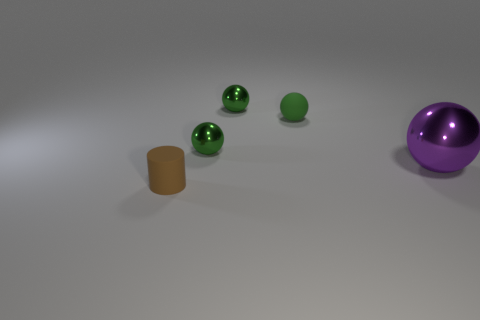Do the small thing that is in front of the large purple metallic object and the tiny sphere that is behind the matte sphere have the same material?
Your answer should be compact. No. There is a tiny green object that is on the right side of the tiny green object behind the rubber ball on the left side of the purple ball; what is its material?
Keep it short and to the point. Rubber. There is a big purple sphere; are there any tiny cylinders in front of it?
Provide a short and direct response. Yes. What is the shape of the purple object?
Your response must be concise. Sphere. There is a small rubber object that is left of the green metallic sphere that is behind the rubber thing that is right of the tiny cylinder; what shape is it?
Offer a terse response. Cylinder. What number of other objects are there of the same shape as the tiny brown matte object?
Your answer should be very brief. 0. The green object that is in front of the matte object that is behind the big purple object is made of what material?
Ensure brevity in your answer.  Metal. Is there any other thing that has the same size as the purple sphere?
Offer a terse response. No. Do the purple object and the small thing in front of the large object have the same material?
Provide a succinct answer. No. What is the color of the tiny metallic ball in front of the rubber object behind the big purple object?
Your answer should be compact. Green. 